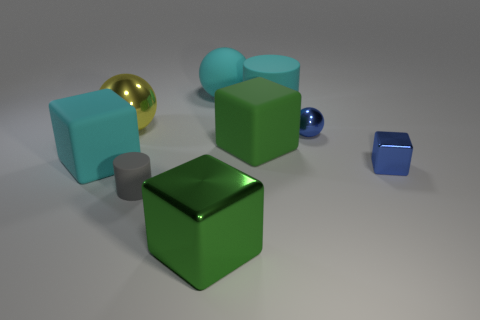Are the large cyan thing that is left of the big yellow object and the large ball to the right of the big shiny cube made of the same material?
Provide a short and direct response. Yes. Are there an equal number of tiny matte cylinders right of the small matte cylinder and tiny blue spheres that are in front of the yellow sphere?
Your answer should be very brief. No. How many other big cylinders have the same material as the large cyan cylinder?
Provide a succinct answer. 0. What shape is the small object that is the same color as the small shiny ball?
Keep it short and to the point. Cube. There is a shiny block behind the big green cube to the left of the green matte block; how big is it?
Give a very brief answer. Small. Is the shape of the thing in front of the small matte cylinder the same as the cyan matte thing to the left of the big yellow shiny ball?
Ensure brevity in your answer.  Yes. Is the number of blue things right of the big green matte cube the same as the number of yellow shiny balls?
Make the answer very short. No. There is a big rubber object that is the same shape as the small gray thing; what is its color?
Ensure brevity in your answer.  Cyan. Is the cylinder that is to the left of the big green shiny block made of the same material as the large yellow sphere?
Offer a very short reply. No. How many small things are either green blocks or blue objects?
Ensure brevity in your answer.  2. 